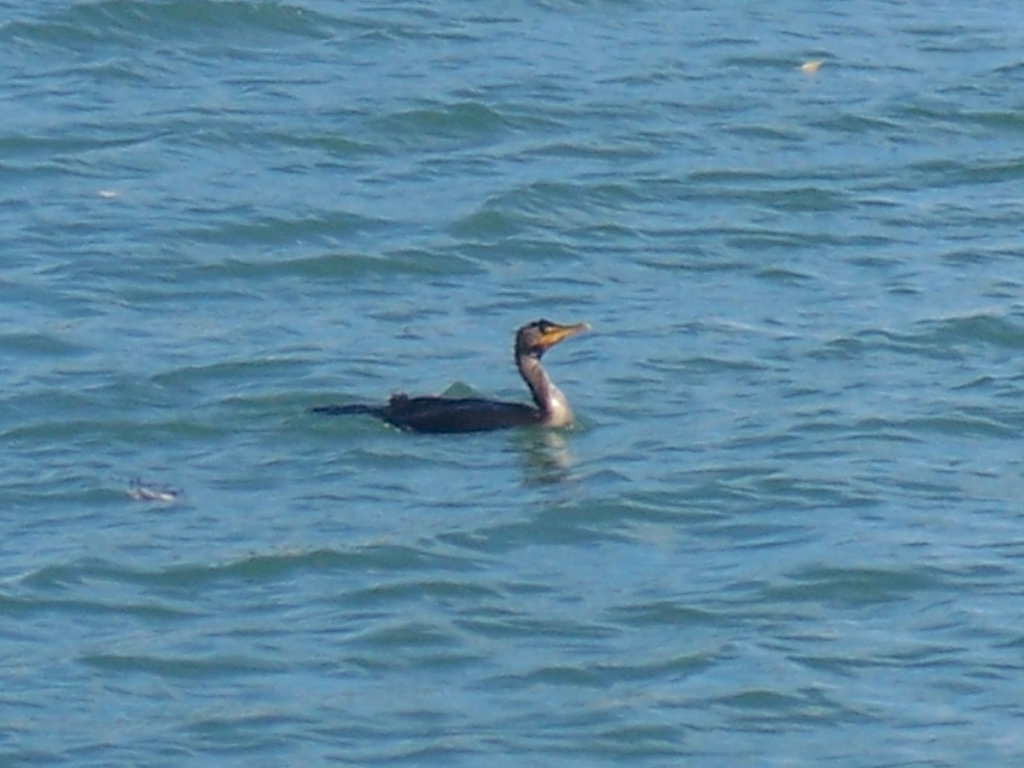What kind of bird is depicted in this image? The bird in the image appears to be a cormorant, distinguished by its dark plumage and the characteristic posture of spreading its wings, which is common among these birds for drying their feathers. Can you tell me about the habitat preferences of such birds? Cormorants are typically found near rivers, lakes, and coastal areas. They prefer locations with ample aquatic life where they can dive and fish. These birds can often be seen perched near water, and because their feathers don't repel water as efficiently as other waterbirds, they'll frequently spread their wings to dry. 